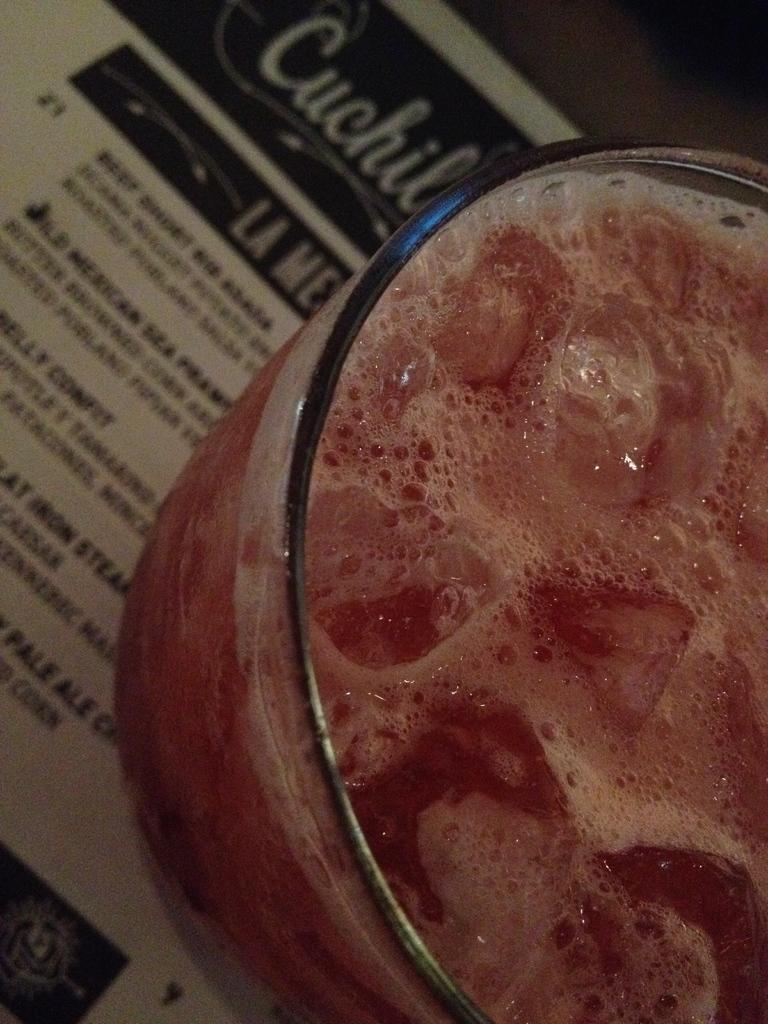Please provide a concise description of this image. Here we can see a glass with drink and a paper. 